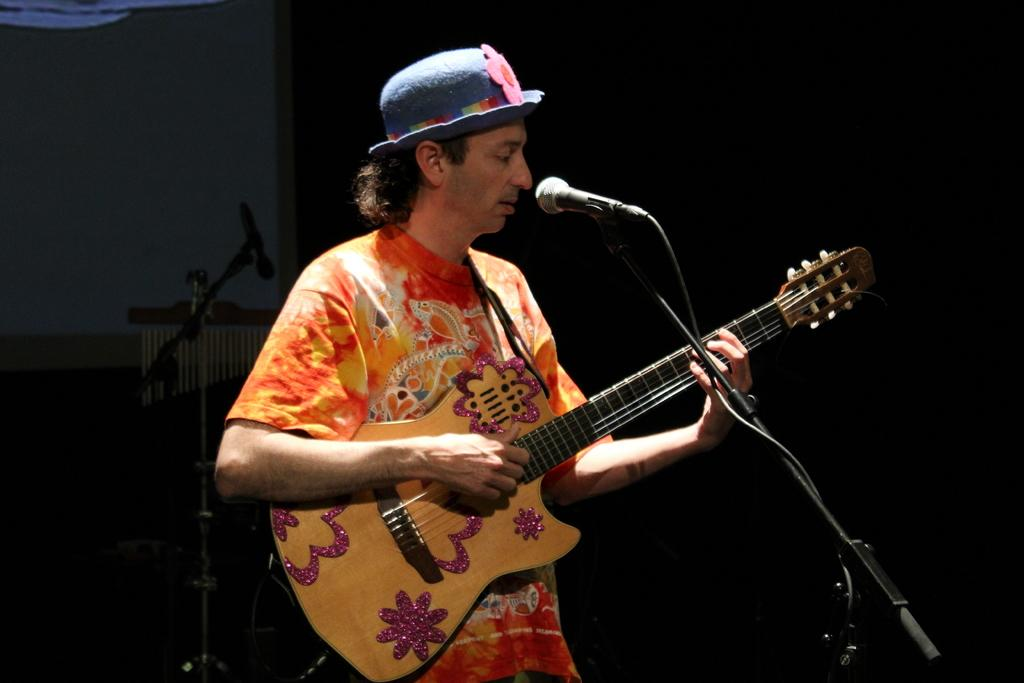Who is the main subject in the image? There is a man in the image. What is the man doing in the image? The man is standing in the image. What object is the man holding in his hand? The man is holding a guitar in his hand. What is the purpose of the microphone and stand in front of the man? The microphone and stand are likely used for amplifying the man's voice while he plays the guitar. What type of wood is the man using to guide his finger in the image? There is no wood or finger guiding activity present in the image. 